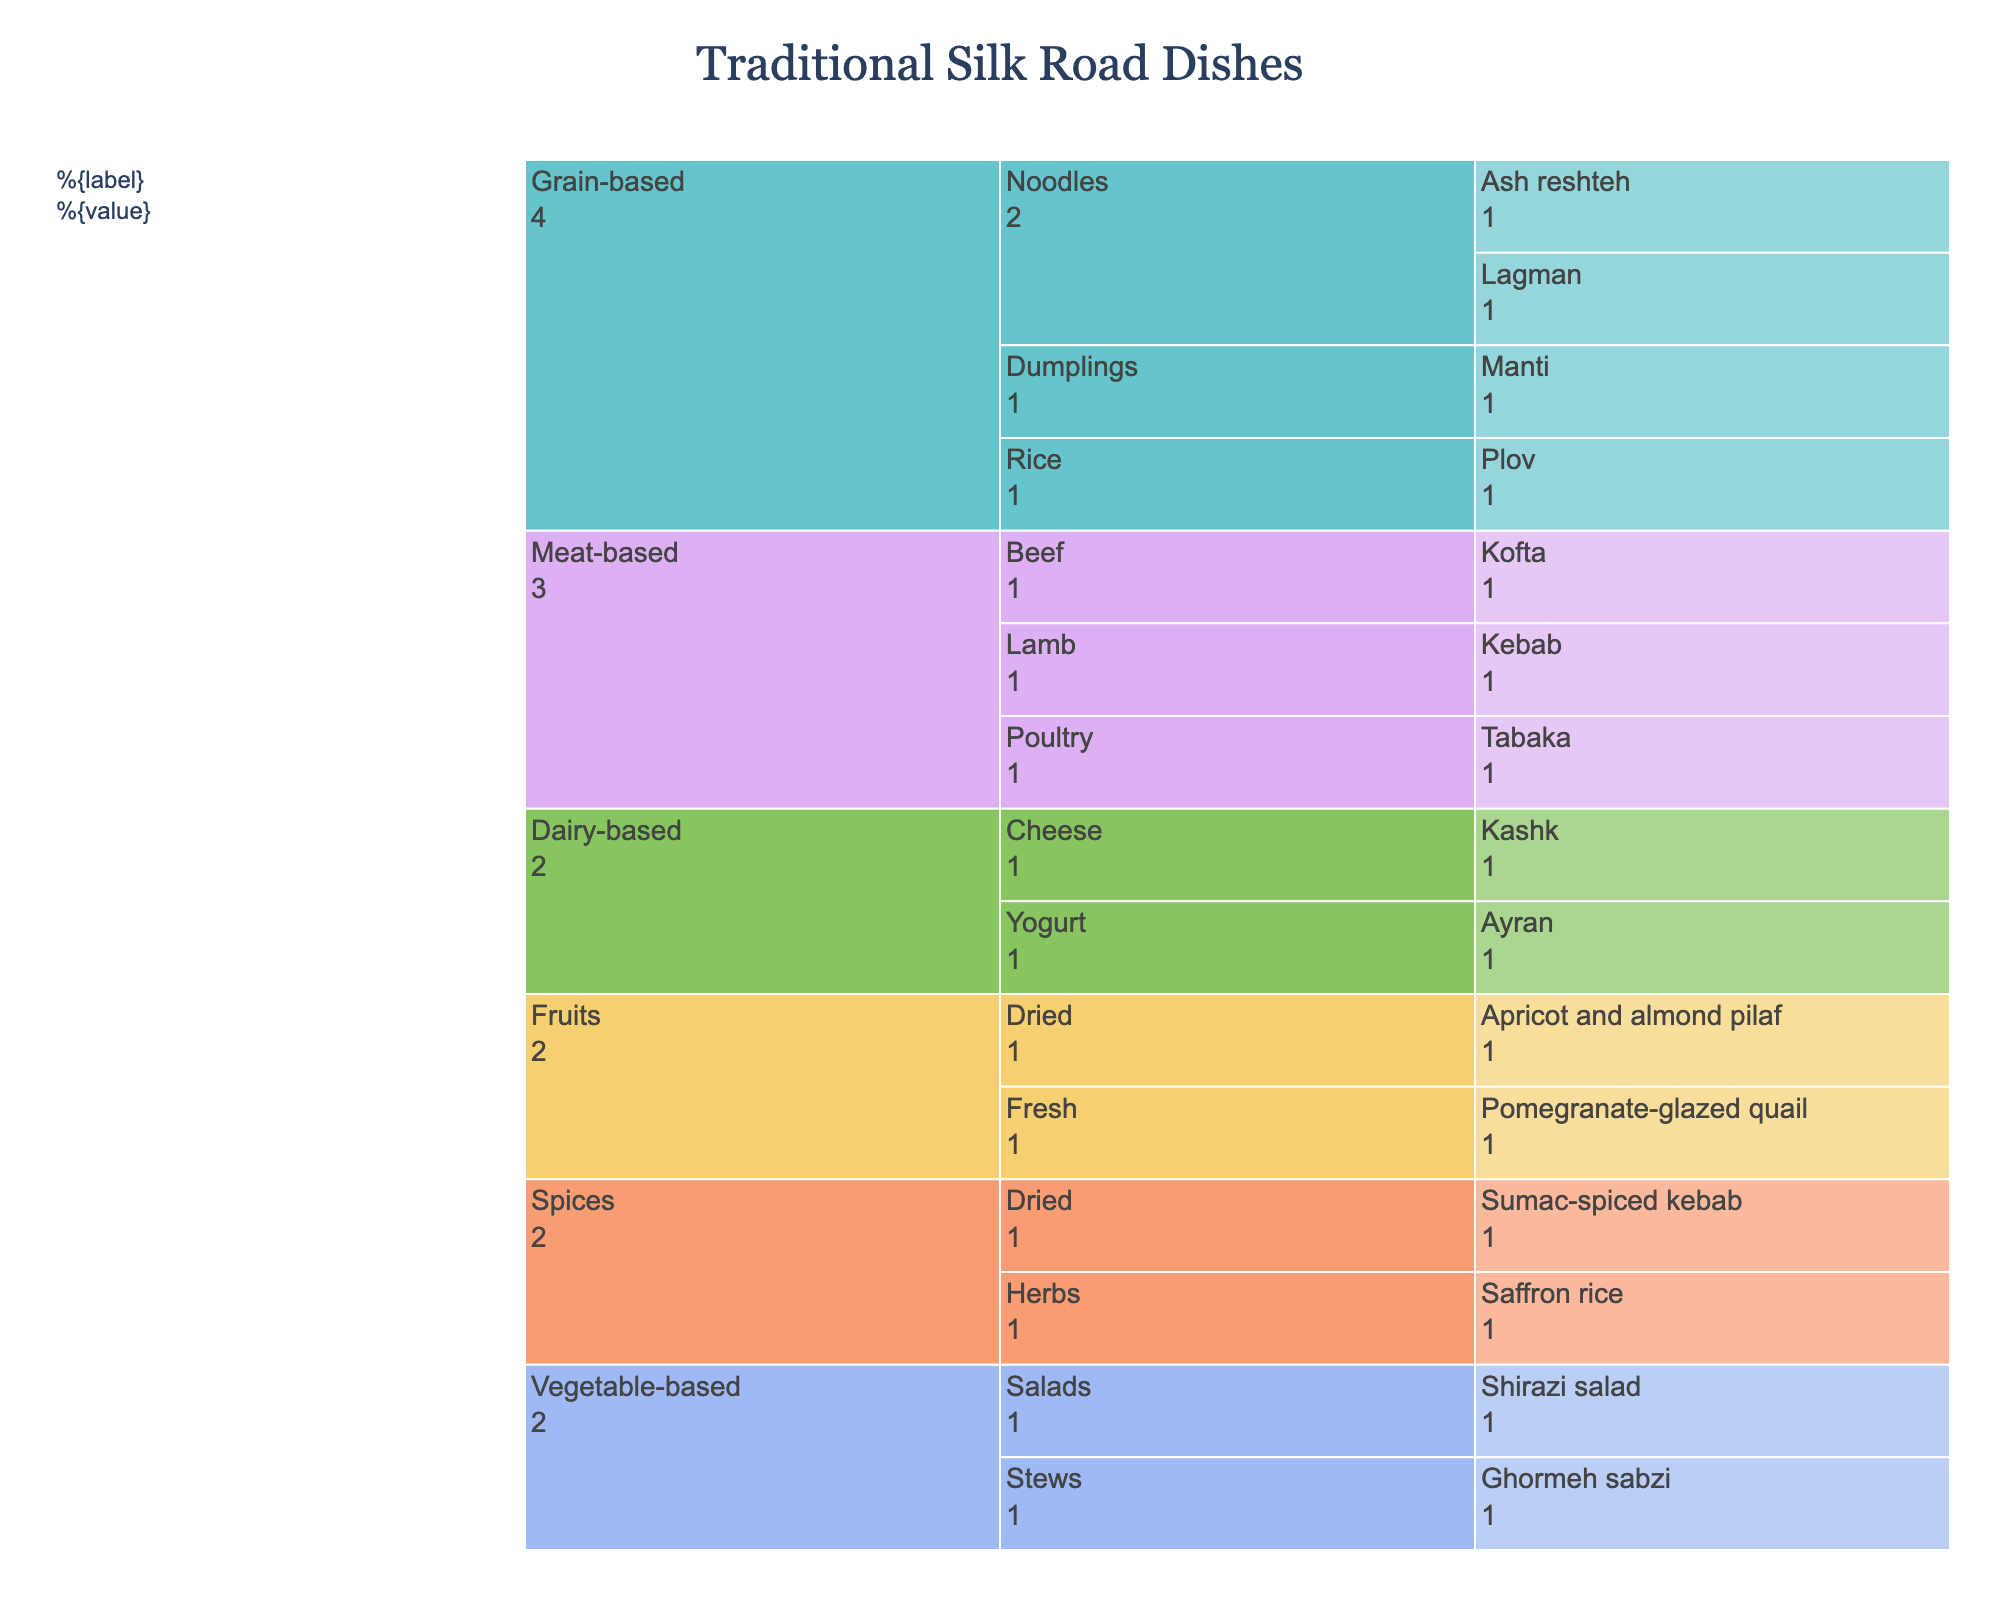What is the title of the chart? The title is displayed at the top of the chart and indicates what the chart is about.
Answer: Traditional Silk Road Dishes How many main categories are there in the chart? Count the number of distinct main branches stemming from the root in the icicle chart.
Answer: 5 Which dish category has the most subcategories? Identify the main category with the most branches below it.
Answer: Grain-based Which subcategory within the Grain-based category contains the most dishes? Look at the subcategories under Grain-based and count the number of dishes within each.
Answer: Noodles How many total dishes are in the Meat-based category? Count the number of dishes listed under all subcategories within the Meat-based category.
Answer: 3 Are there more dishes in the Fruits category or the Spices category? Compare the count of dishes within Fruits and Spices categories.
Answer: Fruits What is the only dish listed under the Dairy-based category that is related to yogurt? Identify the dish listed under the subcategory "Yogurt" in the Dairy-based category.
Answer: Ayran How many different subcategories does the Vegetable-based category contain? Count the subcategories listed under the main Vegetable-based category.
Answer: 2 Which category has the fewest number of dishes? Identify the category with the least count of dishes.
Answer: Dairy-based Is the number of dishes in the Vegetable-based category greater than, less than, or equal to the number of dishes in the Grain-based category? Compare the total count of dishes between Vegetable-based and Grain-based categories.
Answer: Less than 